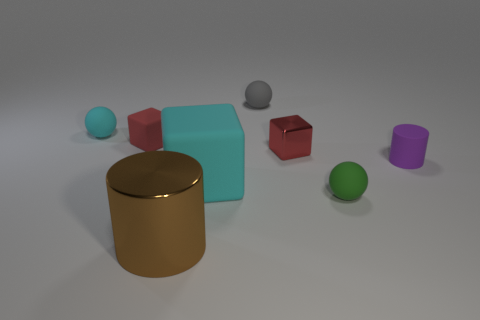What size is the gray thing that is the same material as the cyan cube?
Provide a short and direct response. Small. There is a matte sphere that is on the left side of the big cyan thing; what is its size?
Your response must be concise. Small. How many other cubes have the same size as the metal cube?
Make the answer very short. 1. The matte block that is the same color as the metal block is what size?
Keep it short and to the point. Small. Is there another cube that has the same color as the tiny matte cube?
Provide a succinct answer. Yes. There is a metallic object that is the same size as the gray rubber sphere; what is its color?
Provide a short and direct response. Red. There is a metal cube; is it the same color as the tiny block behind the red metallic block?
Ensure brevity in your answer.  Yes. The big metal cylinder has what color?
Provide a short and direct response. Brown. There is a small red object that is on the left side of the red shiny object; what material is it?
Provide a short and direct response. Rubber. The brown thing that is the same shape as the purple thing is what size?
Make the answer very short. Large. 